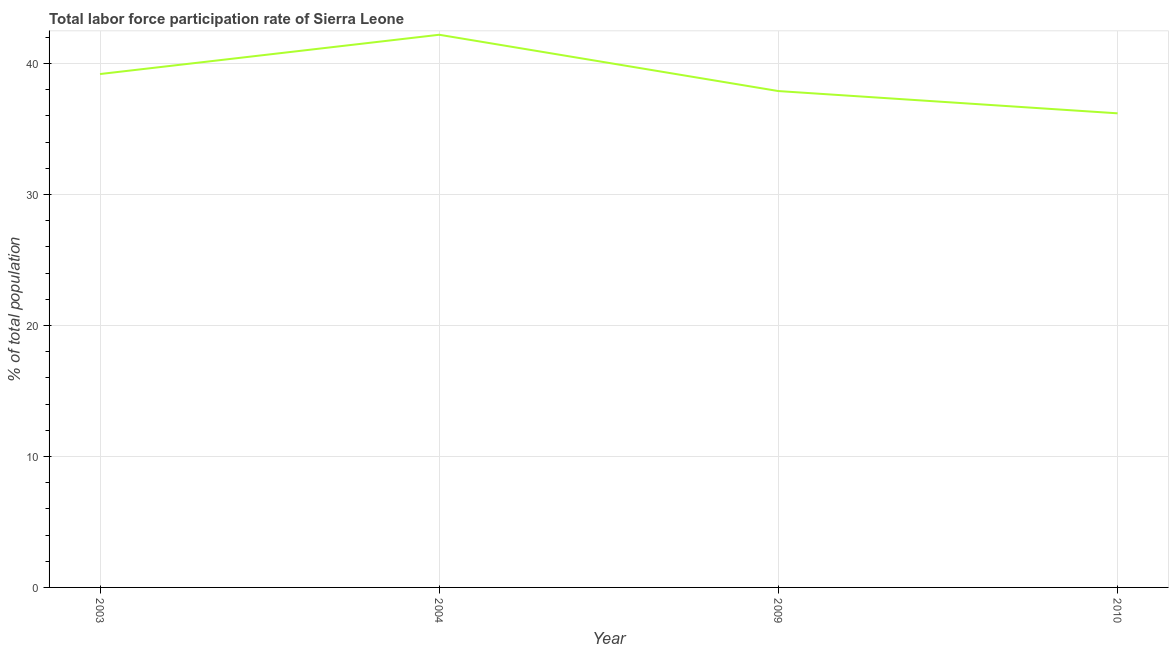What is the total labor force participation rate in 2004?
Make the answer very short. 42.2. Across all years, what is the maximum total labor force participation rate?
Make the answer very short. 42.2. Across all years, what is the minimum total labor force participation rate?
Your answer should be compact. 36.2. In which year was the total labor force participation rate maximum?
Provide a short and direct response. 2004. In which year was the total labor force participation rate minimum?
Provide a short and direct response. 2010. What is the sum of the total labor force participation rate?
Ensure brevity in your answer.  155.5. What is the difference between the total labor force participation rate in 2009 and 2010?
Your answer should be very brief. 1.7. What is the average total labor force participation rate per year?
Ensure brevity in your answer.  38.88. What is the median total labor force participation rate?
Provide a short and direct response. 38.55. What is the ratio of the total labor force participation rate in 2003 to that in 2004?
Your response must be concise. 0.93. Is the total labor force participation rate in 2004 less than that in 2009?
Make the answer very short. No. Is the difference between the total labor force participation rate in 2004 and 2009 greater than the difference between any two years?
Your answer should be very brief. No. What is the difference between the highest and the lowest total labor force participation rate?
Provide a succinct answer. 6. In how many years, is the total labor force participation rate greater than the average total labor force participation rate taken over all years?
Your response must be concise. 2. How many years are there in the graph?
Offer a very short reply. 4. Does the graph contain any zero values?
Offer a very short reply. No. What is the title of the graph?
Your response must be concise. Total labor force participation rate of Sierra Leone. What is the label or title of the X-axis?
Keep it short and to the point. Year. What is the label or title of the Y-axis?
Provide a short and direct response. % of total population. What is the % of total population of 2003?
Your response must be concise. 39.2. What is the % of total population of 2004?
Your answer should be compact. 42.2. What is the % of total population of 2009?
Ensure brevity in your answer.  37.9. What is the % of total population in 2010?
Ensure brevity in your answer.  36.2. What is the difference between the % of total population in 2003 and 2004?
Make the answer very short. -3. What is the difference between the % of total population in 2003 and 2010?
Ensure brevity in your answer.  3. What is the difference between the % of total population in 2004 and 2010?
Provide a succinct answer. 6. What is the difference between the % of total population in 2009 and 2010?
Your response must be concise. 1.7. What is the ratio of the % of total population in 2003 to that in 2004?
Ensure brevity in your answer.  0.93. What is the ratio of the % of total population in 2003 to that in 2009?
Keep it short and to the point. 1.03. What is the ratio of the % of total population in 2003 to that in 2010?
Offer a very short reply. 1.08. What is the ratio of the % of total population in 2004 to that in 2009?
Your answer should be very brief. 1.11. What is the ratio of the % of total population in 2004 to that in 2010?
Provide a succinct answer. 1.17. What is the ratio of the % of total population in 2009 to that in 2010?
Your answer should be compact. 1.05. 